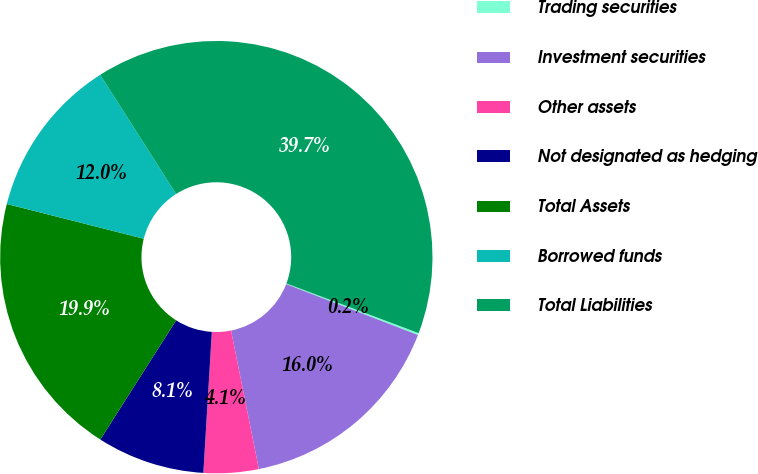<chart> <loc_0><loc_0><loc_500><loc_500><pie_chart><fcel>Trading securities<fcel>Investment securities<fcel>Other assets<fcel>Not designated as hedging<fcel>Total Assets<fcel>Borrowed funds<fcel>Total Liabilities<nl><fcel>0.15%<fcel>15.98%<fcel>4.11%<fcel>8.06%<fcel>19.94%<fcel>12.02%<fcel>39.74%<nl></chart> 